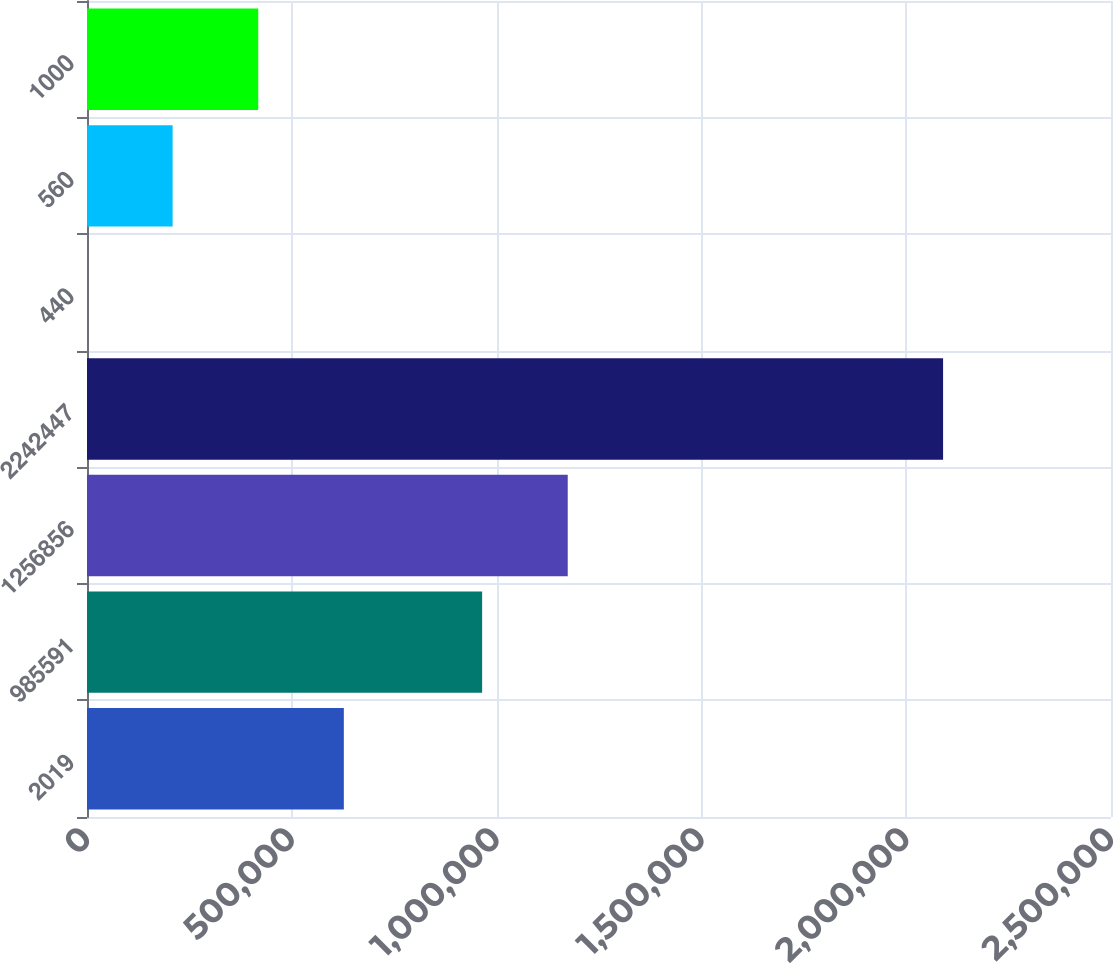<chart> <loc_0><loc_0><loc_500><loc_500><bar_chart><fcel>2019<fcel>985591<fcel>1256856<fcel>2242447<fcel>440<fcel>560<fcel>1000<nl><fcel>627045<fcel>964662<fcel>1.17366e+06<fcel>2.09004e+06<fcel>46.2<fcel>209046<fcel>418045<nl></chart> 